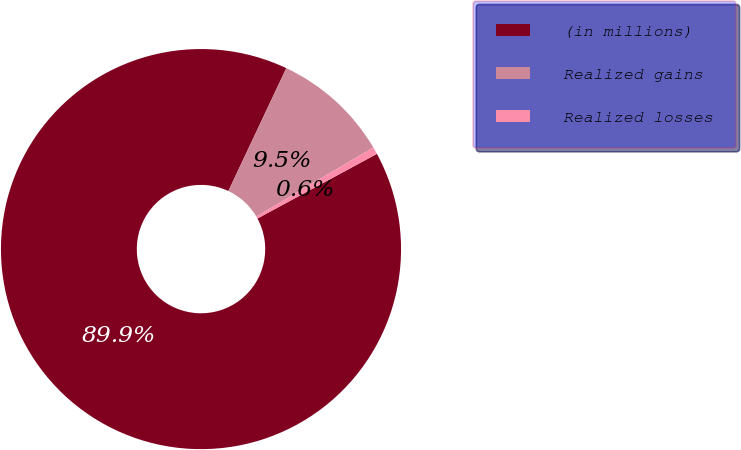<chart> <loc_0><loc_0><loc_500><loc_500><pie_chart><fcel>(in millions)<fcel>Realized gains<fcel>Realized losses<nl><fcel>89.91%<fcel>9.51%<fcel>0.58%<nl></chart> 